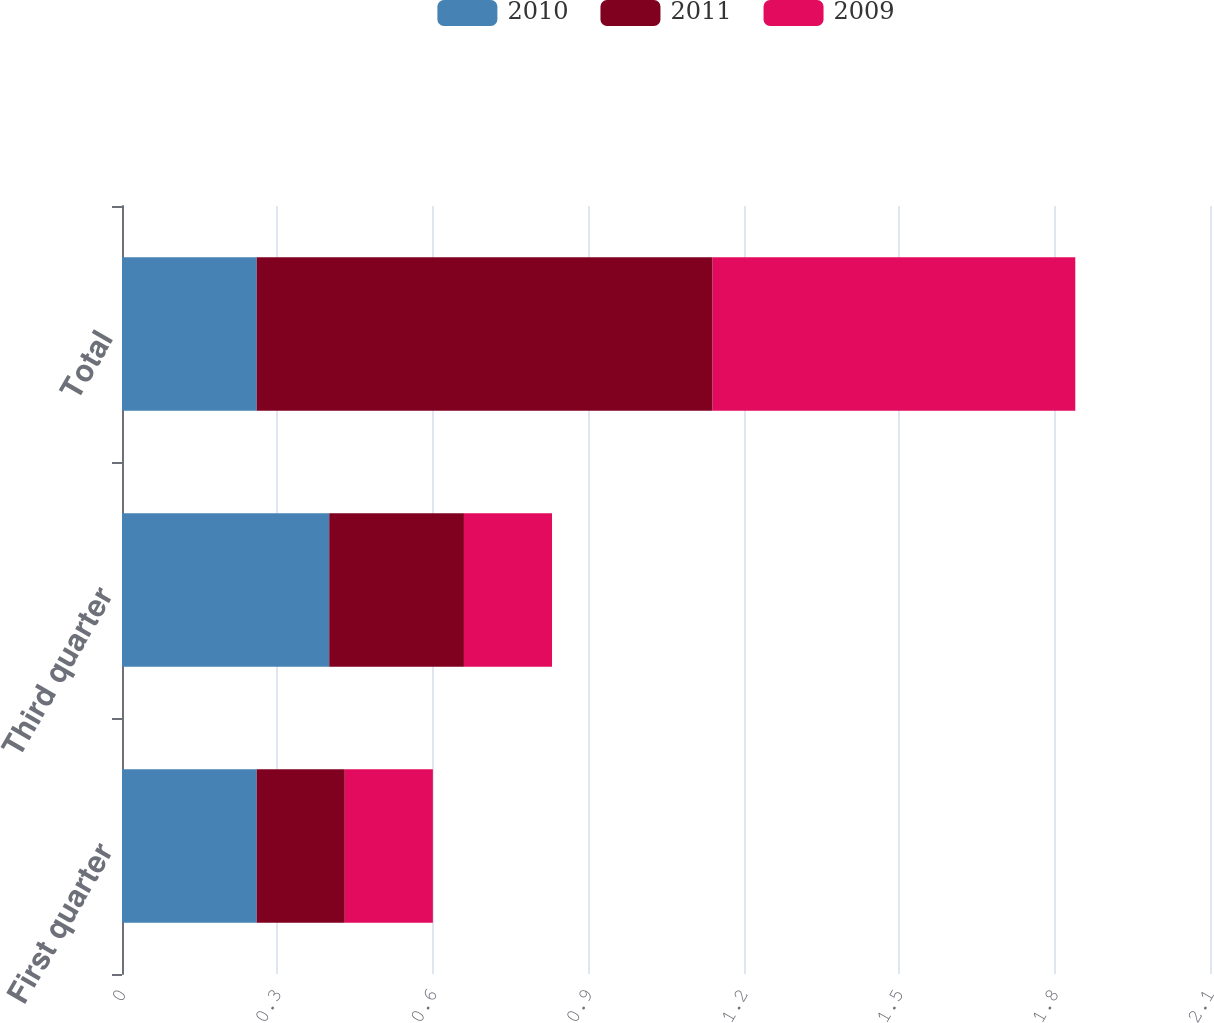Convert chart. <chart><loc_0><loc_0><loc_500><loc_500><stacked_bar_chart><ecel><fcel>First quarter<fcel>Third quarter<fcel>Total<nl><fcel>2010<fcel>0.26<fcel>0.4<fcel>0.26<nl><fcel>2011<fcel>0.17<fcel>0.26<fcel>0.88<nl><fcel>2009<fcel>0.17<fcel>0.17<fcel>0.7<nl></chart> 